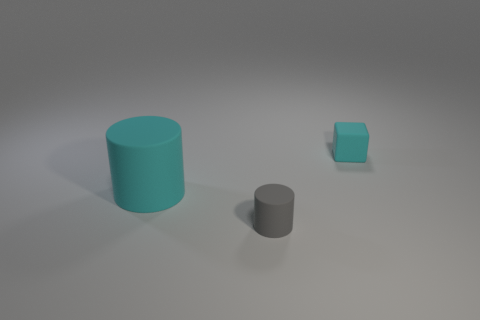There is a cyan thing left of the small gray object; does it have the same size as the cyan matte thing that is right of the large cyan rubber thing?
Provide a succinct answer. No. Is the size of the gray matte cylinder the same as the matte thing that is left of the tiny matte cylinder?
Your answer should be compact. No. What number of other objects are there of the same color as the large object?
Make the answer very short. 1. Are there any other things that have the same size as the cyan matte cylinder?
Ensure brevity in your answer.  No. Are there any tiny matte cylinders?
Keep it short and to the point. Yes. Is there a cyan cube that has the same material as the small cyan thing?
Provide a short and direct response. No. There is a cyan cube that is the same size as the gray cylinder; what material is it?
Ensure brevity in your answer.  Rubber. What number of gray objects have the same shape as the tiny cyan object?
Offer a very short reply. 0. What size is the gray object that is made of the same material as the block?
Keep it short and to the point. Small. What number of gray things are the same size as the cyan cube?
Ensure brevity in your answer.  1. 